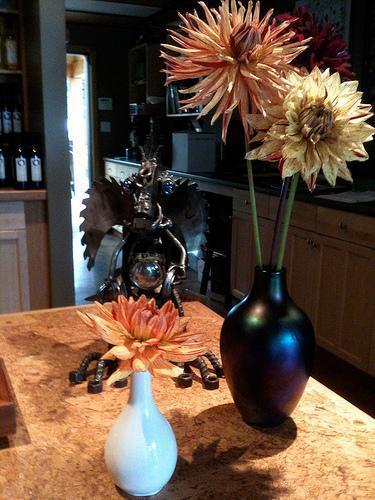How many flowers in white vase?
Give a very brief answer. 1. How many vases have flowers in them?
Give a very brief answer. 2. 